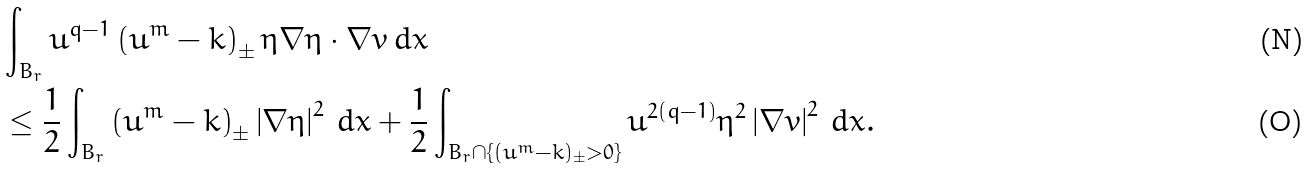Convert formula to latex. <formula><loc_0><loc_0><loc_500><loc_500>& \int _ { B _ { r } } u ^ { q - 1 } \left ( u ^ { m } - k \right ) _ { \pm } \eta \nabla \eta \cdot \nabla v \, d x \\ & \leq \frac { 1 } { 2 } \int _ { B _ { r } } \left ( u ^ { m } - k \right ) _ { \pm } \left | \nabla \eta \right | ^ { 2 } \, d x + \frac { 1 } { 2 } \int _ { B _ { r } \cap \{ ( u ^ { m } - k ) _ { \pm } > 0 \} } u ^ { 2 ( q - 1 ) } \eta ^ { 2 } \left | \nabla v \right | ^ { 2 } \, d x .</formula> 